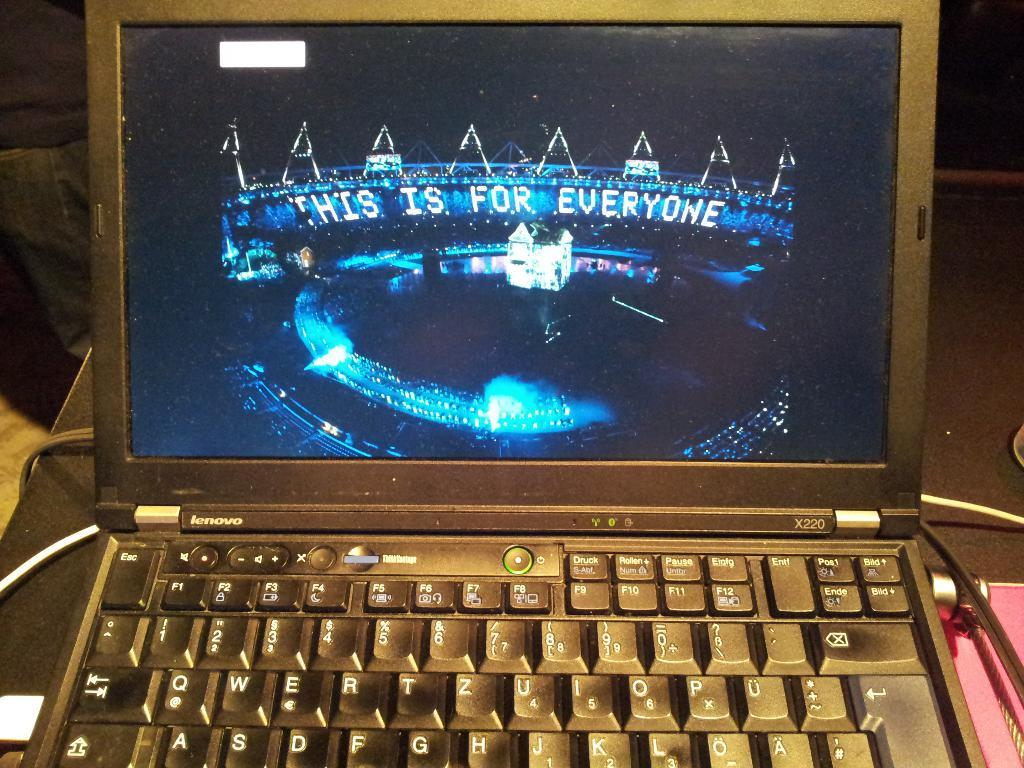<image>
Present a compact description of the photo's key features. an open computer with the words 'this is for everyone' on the screen 